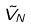<formula> <loc_0><loc_0><loc_500><loc_500>\tilde { V } _ { N }</formula> 